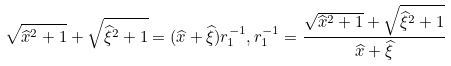Convert formula to latex. <formula><loc_0><loc_0><loc_500><loc_500>\sqrt { \widehat { x } ^ { 2 } + 1 } + \sqrt { \widehat { \xi } ^ { 2 } + 1 } = ( \widehat { x } + \widehat { \xi } ) r ^ { - 1 } _ { 1 } , r _ { 1 } ^ { - 1 } = \frac { \sqrt { \widehat { x } ^ { 2 } + 1 } + \sqrt { \widehat { \xi } ^ { 2 } + 1 } } { \widehat { x } + \widehat { \xi } }</formula> 